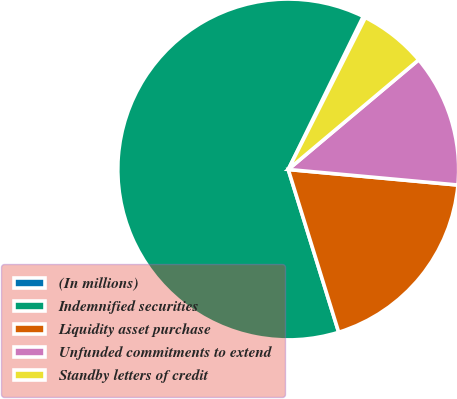Convert chart. <chart><loc_0><loc_0><loc_500><loc_500><pie_chart><fcel>(In millions)<fcel>Indemnified securities<fcel>Liquidity asset purchase<fcel>Unfunded commitments to extend<fcel>Standby letters of credit<nl><fcel>0.22%<fcel>62.03%<fcel>18.76%<fcel>12.58%<fcel>6.4%<nl></chart> 